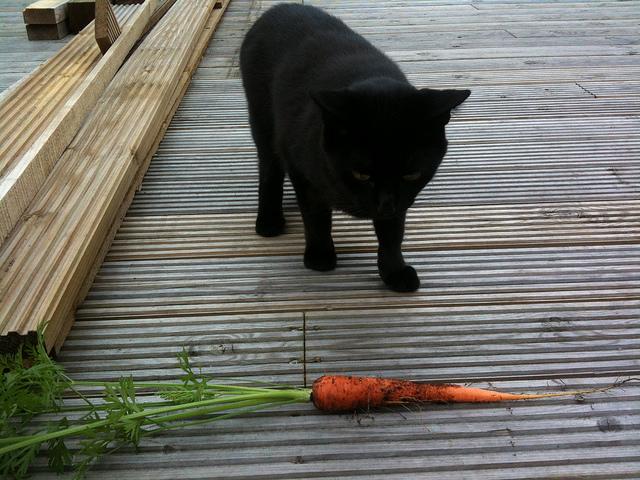What animal is in this picture?
Write a very short answer. Cat. What color is the ground?
Concise answer only. Brown. What vegetable is in the photo?
Concise answer only. Carrot. Will the pig's feet fit into the cracks on the boardwalk?
Keep it brief. No. 